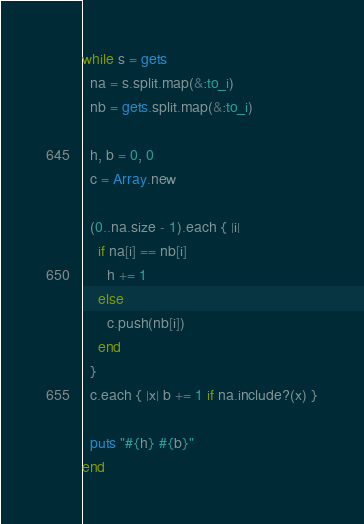Convert code to text. <code><loc_0><loc_0><loc_500><loc_500><_Ruby_>while s = gets
  na = s.split.map(&:to_i)
  nb = gets.split.map(&:to_i)

  h, b = 0, 0
  c = Array.new

  (0..na.size - 1).each { |i| 
    if na[i] == nb[i]
      h += 1
    else
      c.push(nb[i])
    end 
  }
  c.each { |x| b += 1 if na.include?(x) }

  puts "#{h} #{b}"
end</code> 